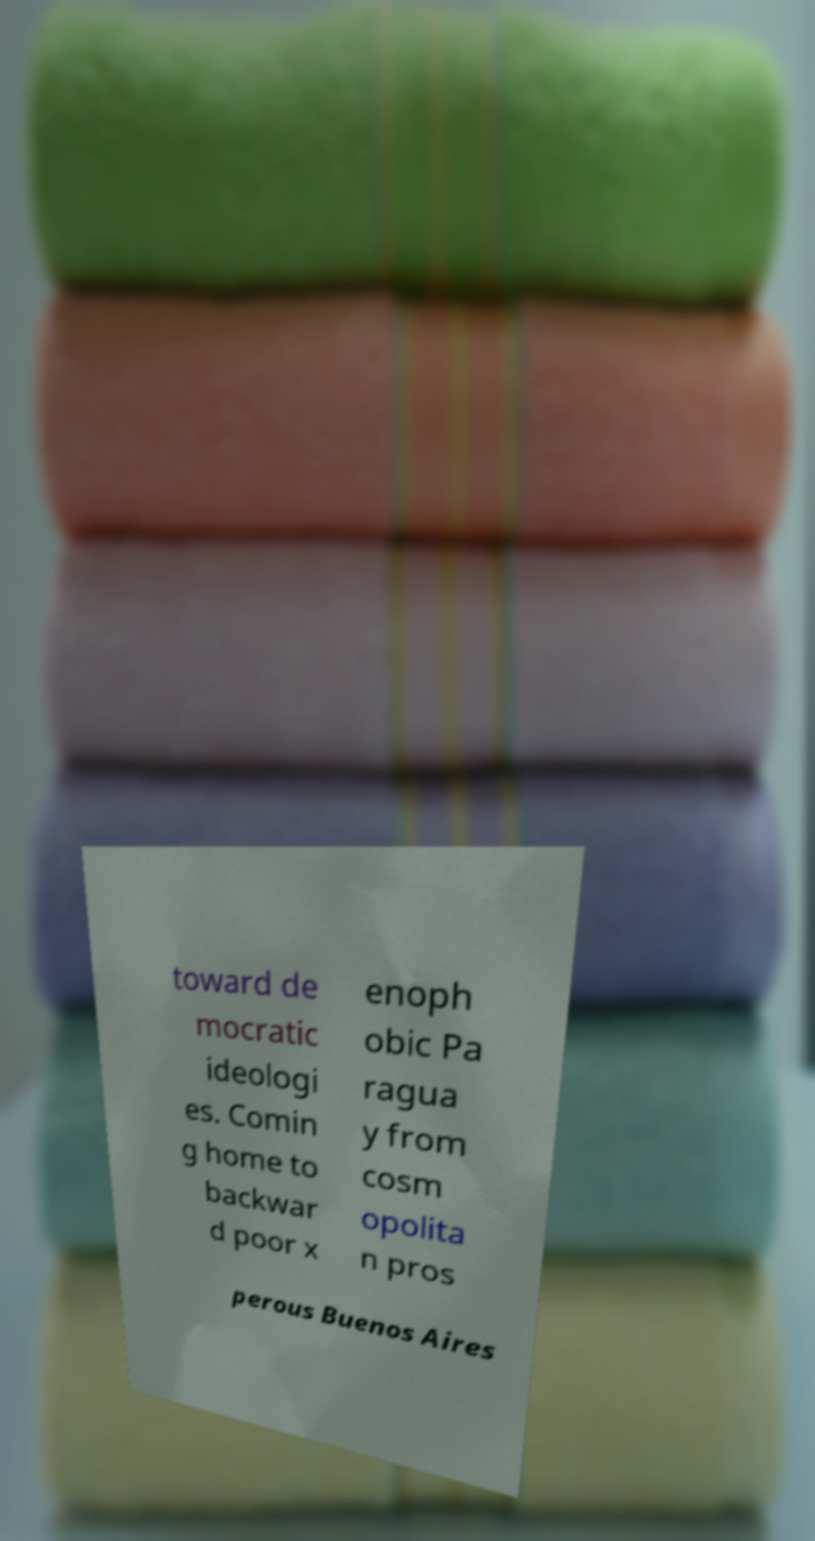For documentation purposes, I need the text within this image transcribed. Could you provide that? toward de mocratic ideologi es. Comin g home to backwar d poor x enoph obic Pa ragua y from cosm opolita n pros perous Buenos Aires 